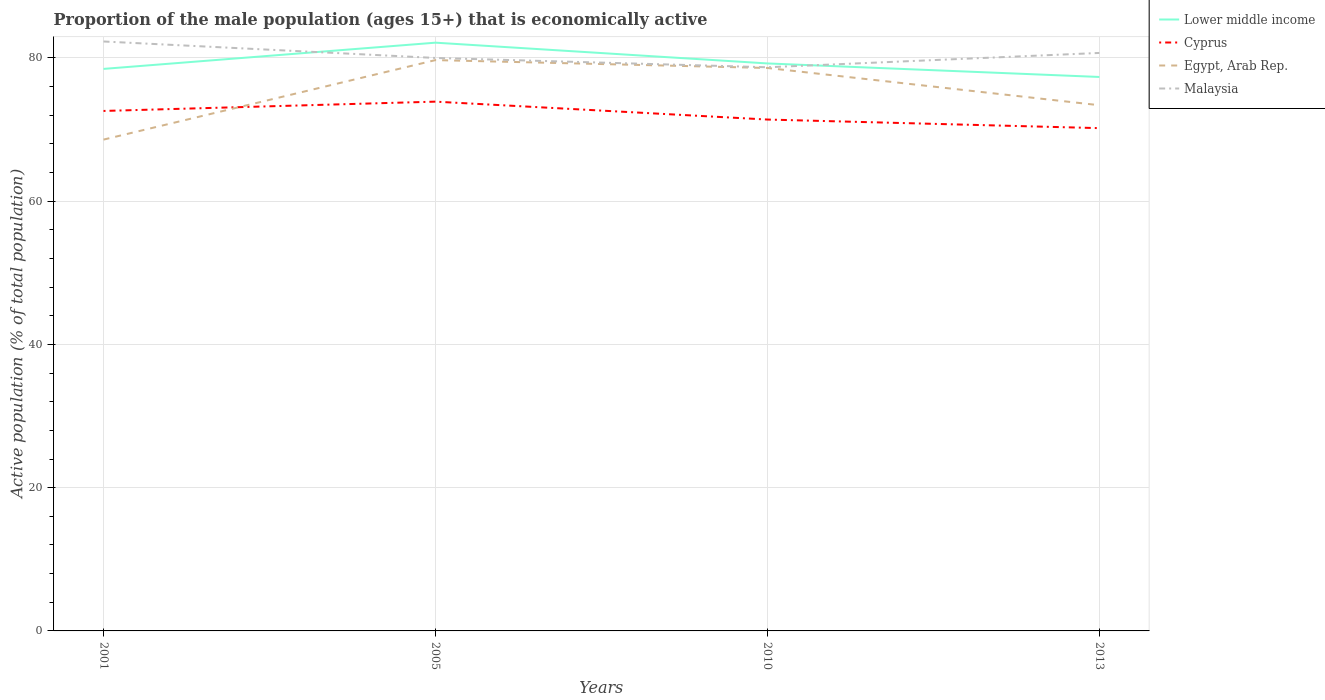How many different coloured lines are there?
Keep it short and to the point. 4. Is the number of lines equal to the number of legend labels?
Make the answer very short. Yes. Across all years, what is the maximum proportion of the male population that is economically active in Egypt, Arab Rep.?
Make the answer very short. 68.6. What is the total proportion of the male population that is economically active in Malaysia in the graph?
Keep it short and to the point. 3.6. What is the difference between the highest and the second highest proportion of the male population that is economically active in Lower middle income?
Your response must be concise. 4.79. What is the difference between the highest and the lowest proportion of the male population that is economically active in Malaysia?
Ensure brevity in your answer.  2. How many lines are there?
Keep it short and to the point. 4. How many years are there in the graph?
Give a very brief answer. 4. What is the difference between two consecutive major ticks on the Y-axis?
Provide a short and direct response. 20. Does the graph contain any zero values?
Your response must be concise. No. Does the graph contain grids?
Give a very brief answer. Yes. What is the title of the graph?
Give a very brief answer. Proportion of the male population (ages 15+) that is economically active. What is the label or title of the X-axis?
Ensure brevity in your answer.  Years. What is the label or title of the Y-axis?
Your answer should be very brief. Active population (% of total population). What is the Active population (% of total population) of Lower middle income in 2001?
Your answer should be very brief. 78.47. What is the Active population (% of total population) in Cyprus in 2001?
Give a very brief answer. 72.6. What is the Active population (% of total population) in Egypt, Arab Rep. in 2001?
Provide a short and direct response. 68.6. What is the Active population (% of total population) of Malaysia in 2001?
Your response must be concise. 82.3. What is the Active population (% of total population) in Lower middle income in 2005?
Offer a very short reply. 82.13. What is the Active population (% of total population) in Cyprus in 2005?
Offer a very short reply. 73.9. What is the Active population (% of total population) in Egypt, Arab Rep. in 2005?
Ensure brevity in your answer.  79.7. What is the Active population (% of total population) in Malaysia in 2005?
Your response must be concise. 80. What is the Active population (% of total population) in Lower middle income in 2010?
Your answer should be compact. 79.24. What is the Active population (% of total population) of Cyprus in 2010?
Your response must be concise. 71.4. What is the Active population (% of total population) of Egypt, Arab Rep. in 2010?
Provide a succinct answer. 78.6. What is the Active population (% of total population) of Malaysia in 2010?
Provide a succinct answer. 78.7. What is the Active population (% of total population) of Lower middle income in 2013?
Provide a short and direct response. 77.34. What is the Active population (% of total population) of Cyprus in 2013?
Make the answer very short. 70.2. What is the Active population (% of total population) of Egypt, Arab Rep. in 2013?
Your answer should be very brief. 73.4. What is the Active population (% of total population) of Malaysia in 2013?
Offer a very short reply. 80.7. Across all years, what is the maximum Active population (% of total population) of Lower middle income?
Your response must be concise. 82.13. Across all years, what is the maximum Active population (% of total population) of Cyprus?
Give a very brief answer. 73.9. Across all years, what is the maximum Active population (% of total population) in Egypt, Arab Rep.?
Ensure brevity in your answer.  79.7. Across all years, what is the maximum Active population (% of total population) in Malaysia?
Make the answer very short. 82.3. Across all years, what is the minimum Active population (% of total population) in Lower middle income?
Keep it short and to the point. 77.34. Across all years, what is the minimum Active population (% of total population) of Cyprus?
Ensure brevity in your answer.  70.2. Across all years, what is the minimum Active population (% of total population) of Egypt, Arab Rep.?
Your answer should be compact. 68.6. Across all years, what is the minimum Active population (% of total population) of Malaysia?
Offer a very short reply. 78.7. What is the total Active population (% of total population) of Lower middle income in the graph?
Keep it short and to the point. 317.19. What is the total Active population (% of total population) in Cyprus in the graph?
Your answer should be very brief. 288.1. What is the total Active population (% of total population) of Egypt, Arab Rep. in the graph?
Ensure brevity in your answer.  300.3. What is the total Active population (% of total population) in Malaysia in the graph?
Make the answer very short. 321.7. What is the difference between the Active population (% of total population) of Lower middle income in 2001 and that in 2005?
Your response must be concise. -3.66. What is the difference between the Active population (% of total population) of Cyprus in 2001 and that in 2005?
Offer a very short reply. -1.3. What is the difference between the Active population (% of total population) in Egypt, Arab Rep. in 2001 and that in 2005?
Make the answer very short. -11.1. What is the difference between the Active population (% of total population) in Lower middle income in 2001 and that in 2010?
Give a very brief answer. -0.76. What is the difference between the Active population (% of total population) of Egypt, Arab Rep. in 2001 and that in 2010?
Your answer should be compact. -10. What is the difference between the Active population (% of total population) in Malaysia in 2001 and that in 2010?
Offer a very short reply. 3.6. What is the difference between the Active population (% of total population) of Lower middle income in 2001 and that in 2013?
Offer a terse response. 1.13. What is the difference between the Active population (% of total population) of Egypt, Arab Rep. in 2001 and that in 2013?
Ensure brevity in your answer.  -4.8. What is the difference between the Active population (% of total population) of Lower middle income in 2005 and that in 2010?
Provide a short and direct response. 2.9. What is the difference between the Active population (% of total population) of Cyprus in 2005 and that in 2010?
Give a very brief answer. 2.5. What is the difference between the Active population (% of total population) in Malaysia in 2005 and that in 2010?
Offer a terse response. 1.3. What is the difference between the Active population (% of total population) in Lower middle income in 2005 and that in 2013?
Your response must be concise. 4.79. What is the difference between the Active population (% of total population) in Cyprus in 2005 and that in 2013?
Provide a succinct answer. 3.7. What is the difference between the Active population (% of total population) of Egypt, Arab Rep. in 2005 and that in 2013?
Make the answer very short. 6.3. What is the difference between the Active population (% of total population) in Malaysia in 2005 and that in 2013?
Provide a short and direct response. -0.7. What is the difference between the Active population (% of total population) in Lower middle income in 2010 and that in 2013?
Your response must be concise. 1.89. What is the difference between the Active population (% of total population) in Cyprus in 2010 and that in 2013?
Your answer should be compact. 1.2. What is the difference between the Active population (% of total population) in Lower middle income in 2001 and the Active population (% of total population) in Cyprus in 2005?
Your response must be concise. 4.57. What is the difference between the Active population (% of total population) in Lower middle income in 2001 and the Active population (% of total population) in Egypt, Arab Rep. in 2005?
Offer a very short reply. -1.23. What is the difference between the Active population (% of total population) in Lower middle income in 2001 and the Active population (% of total population) in Malaysia in 2005?
Provide a succinct answer. -1.53. What is the difference between the Active population (% of total population) in Cyprus in 2001 and the Active population (% of total population) in Egypt, Arab Rep. in 2005?
Ensure brevity in your answer.  -7.1. What is the difference between the Active population (% of total population) in Lower middle income in 2001 and the Active population (% of total population) in Cyprus in 2010?
Ensure brevity in your answer.  7.07. What is the difference between the Active population (% of total population) in Lower middle income in 2001 and the Active population (% of total population) in Egypt, Arab Rep. in 2010?
Your response must be concise. -0.13. What is the difference between the Active population (% of total population) in Lower middle income in 2001 and the Active population (% of total population) in Malaysia in 2010?
Give a very brief answer. -0.23. What is the difference between the Active population (% of total population) of Cyprus in 2001 and the Active population (% of total population) of Egypt, Arab Rep. in 2010?
Offer a very short reply. -6. What is the difference between the Active population (% of total population) of Lower middle income in 2001 and the Active population (% of total population) of Cyprus in 2013?
Give a very brief answer. 8.27. What is the difference between the Active population (% of total population) in Lower middle income in 2001 and the Active population (% of total population) in Egypt, Arab Rep. in 2013?
Offer a very short reply. 5.07. What is the difference between the Active population (% of total population) in Lower middle income in 2001 and the Active population (% of total population) in Malaysia in 2013?
Offer a terse response. -2.23. What is the difference between the Active population (% of total population) of Cyprus in 2001 and the Active population (% of total population) of Egypt, Arab Rep. in 2013?
Your response must be concise. -0.8. What is the difference between the Active population (% of total population) of Egypt, Arab Rep. in 2001 and the Active population (% of total population) of Malaysia in 2013?
Your answer should be compact. -12.1. What is the difference between the Active population (% of total population) in Lower middle income in 2005 and the Active population (% of total population) in Cyprus in 2010?
Your answer should be very brief. 10.73. What is the difference between the Active population (% of total population) of Lower middle income in 2005 and the Active population (% of total population) of Egypt, Arab Rep. in 2010?
Your answer should be compact. 3.53. What is the difference between the Active population (% of total population) in Lower middle income in 2005 and the Active population (% of total population) in Malaysia in 2010?
Make the answer very short. 3.43. What is the difference between the Active population (% of total population) of Cyprus in 2005 and the Active population (% of total population) of Egypt, Arab Rep. in 2010?
Provide a succinct answer. -4.7. What is the difference between the Active population (% of total population) of Egypt, Arab Rep. in 2005 and the Active population (% of total population) of Malaysia in 2010?
Keep it short and to the point. 1. What is the difference between the Active population (% of total population) in Lower middle income in 2005 and the Active population (% of total population) in Cyprus in 2013?
Ensure brevity in your answer.  11.93. What is the difference between the Active population (% of total population) of Lower middle income in 2005 and the Active population (% of total population) of Egypt, Arab Rep. in 2013?
Your answer should be very brief. 8.73. What is the difference between the Active population (% of total population) of Lower middle income in 2005 and the Active population (% of total population) of Malaysia in 2013?
Offer a terse response. 1.43. What is the difference between the Active population (% of total population) in Cyprus in 2005 and the Active population (% of total population) in Egypt, Arab Rep. in 2013?
Your answer should be very brief. 0.5. What is the difference between the Active population (% of total population) of Cyprus in 2005 and the Active population (% of total population) of Malaysia in 2013?
Your response must be concise. -6.8. What is the difference between the Active population (% of total population) in Egypt, Arab Rep. in 2005 and the Active population (% of total population) in Malaysia in 2013?
Offer a terse response. -1. What is the difference between the Active population (% of total population) in Lower middle income in 2010 and the Active population (% of total population) in Cyprus in 2013?
Provide a succinct answer. 9.04. What is the difference between the Active population (% of total population) in Lower middle income in 2010 and the Active population (% of total population) in Egypt, Arab Rep. in 2013?
Ensure brevity in your answer.  5.83. What is the difference between the Active population (% of total population) in Lower middle income in 2010 and the Active population (% of total population) in Malaysia in 2013?
Offer a very short reply. -1.47. What is the difference between the Active population (% of total population) of Cyprus in 2010 and the Active population (% of total population) of Malaysia in 2013?
Give a very brief answer. -9.3. What is the average Active population (% of total population) in Lower middle income per year?
Your response must be concise. 79.3. What is the average Active population (% of total population) of Cyprus per year?
Your answer should be compact. 72.03. What is the average Active population (% of total population) in Egypt, Arab Rep. per year?
Provide a short and direct response. 75.08. What is the average Active population (% of total population) in Malaysia per year?
Keep it short and to the point. 80.42. In the year 2001, what is the difference between the Active population (% of total population) in Lower middle income and Active population (% of total population) in Cyprus?
Ensure brevity in your answer.  5.87. In the year 2001, what is the difference between the Active population (% of total population) of Lower middle income and Active population (% of total population) of Egypt, Arab Rep.?
Provide a succinct answer. 9.87. In the year 2001, what is the difference between the Active population (% of total population) of Lower middle income and Active population (% of total population) of Malaysia?
Make the answer very short. -3.83. In the year 2001, what is the difference between the Active population (% of total population) of Egypt, Arab Rep. and Active population (% of total population) of Malaysia?
Provide a short and direct response. -13.7. In the year 2005, what is the difference between the Active population (% of total population) in Lower middle income and Active population (% of total population) in Cyprus?
Your answer should be compact. 8.23. In the year 2005, what is the difference between the Active population (% of total population) in Lower middle income and Active population (% of total population) in Egypt, Arab Rep.?
Your answer should be very brief. 2.43. In the year 2005, what is the difference between the Active population (% of total population) of Lower middle income and Active population (% of total population) of Malaysia?
Provide a succinct answer. 2.13. In the year 2010, what is the difference between the Active population (% of total population) in Lower middle income and Active population (% of total population) in Cyprus?
Make the answer very short. 7.83. In the year 2010, what is the difference between the Active population (% of total population) of Lower middle income and Active population (% of total population) of Egypt, Arab Rep.?
Offer a very short reply. 0.64. In the year 2010, what is the difference between the Active population (% of total population) of Lower middle income and Active population (% of total population) of Malaysia?
Keep it short and to the point. 0.54. In the year 2010, what is the difference between the Active population (% of total population) of Cyprus and Active population (% of total population) of Egypt, Arab Rep.?
Offer a terse response. -7.2. In the year 2010, what is the difference between the Active population (% of total population) of Cyprus and Active population (% of total population) of Malaysia?
Make the answer very short. -7.3. In the year 2013, what is the difference between the Active population (% of total population) in Lower middle income and Active population (% of total population) in Cyprus?
Your answer should be compact. 7.14. In the year 2013, what is the difference between the Active population (% of total population) of Lower middle income and Active population (% of total population) of Egypt, Arab Rep.?
Provide a succinct answer. 3.94. In the year 2013, what is the difference between the Active population (% of total population) in Lower middle income and Active population (% of total population) in Malaysia?
Your response must be concise. -3.36. In the year 2013, what is the difference between the Active population (% of total population) in Cyprus and Active population (% of total population) in Egypt, Arab Rep.?
Give a very brief answer. -3.2. In the year 2013, what is the difference between the Active population (% of total population) in Cyprus and Active population (% of total population) in Malaysia?
Offer a terse response. -10.5. What is the ratio of the Active population (% of total population) in Lower middle income in 2001 to that in 2005?
Offer a terse response. 0.96. What is the ratio of the Active population (% of total population) in Cyprus in 2001 to that in 2005?
Offer a very short reply. 0.98. What is the ratio of the Active population (% of total population) in Egypt, Arab Rep. in 2001 to that in 2005?
Ensure brevity in your answer.  0.86. What is the ratio of the Active population (% of total population) of Malaysia in 2001 to that in 2005?
Keep it short and to the point. 1.03. What is the ratio of the Active population (% of total population) of Lower middle income in 2001 to that in 2010?
Your answer should be compact. 0.99. What is the ratio of the Active population (% of total population) of Cyprus in 2001 to that in 2010?
Provide a succinct answer. 1.02. What is the ratio of the Active population (% of total population) in Egypt, Arab Rep. in 2001 to that in 2010?
Keep it short and to the point. 0.87. What is the ratio of the Active population (% of total population) of Malaysia in 2001 to that in 2010?
Provide a short and direct response. 1.05. What is the ratio of the Active population (% of total population) in Lower middle income in 2001 to that in 2013?
Offer a terse response. 1.01. What is the ratio of the Active population (% of total population) of Cyprus in 2001 to that in 2013?
Your response must be concise. 1.03. What is the ratio of the Active population (% of total population) of Egypt, Arab Rep. in 2001 to that in 2013?
Provide a short and direct response. 0.93. What is the ratio of the Active population (% of total population) in Malaysia in 2001 to that in 2013?
Offer a terse response. 1.02. What is the ratio of the Active population (% of total population) in Lower middle income in 2005 to that in 2010?
Offer a terse response. 1.04. What is the ratio of the Active population (% of total population) of Cyprus in 2005 to that in 2010?
Offer a terse response. 1.03. What is the ratio of the Active population (% of total population) of Malaysia in 2005 to that in 2010?
Offer a very short reply. 1.02. What is the ratio of the Active population (% of total population) of Lower middle income in 2005 to that in 2013?
Give a very brief answer. 1.06. What is the ratio of the Active population (% of total population) in Cyprus in 2005 to that in 2013?
Offer a terse response. 1.05. What is the ratio of the Active population (% of total population) in Egypt, Arab Rep. in 2005 to that in 2013?
Offer a terse response. 1.09. What is the ratio of the Active population (% of total population) of Lower middle income in 2010 to that in 2013?
Your response must be concise. 1.02. What is the ratio of the Active population (% of total population) of Cyprus in 2010 to that in 2013?
Make the answer very short. 1.02. What is the ratio of the Active population (% of total population) of Egypt, Arab Rep. in 2010 to that in 2013?
Your answer should be compact. 1.07. What is the ratio of the Active population (% of total population) of Malaysia in 2010 to that in 2013?
Offer a very short reply. 0.98. What is the difference between the highest and the second highest Active population (% of total population) in Lower middle income?
Provide a short and direct response. 2.9. What is the difference between the highest and the second highest Active population (% of total population) in Cyprus?
Provide a short and direct response. 1.3. What is the difference between the highest and the second highest Active population (% of total population) of Egypt, Arab Rep.?
Your response must be concise. 1.1. What is the difference between the highest and the second highest Active population (% of total population) of Malaysia?
Offer a very short reply. 1.6. What is the difference between the highest and the lowest Active population (% of total population) in Lower middle income?
Your answer should be compact. 4.79. What is the difference between the highest and the lowest Active population (% of total population) of Cyprus?
Your answer should be compact. 3.7. What is the difference between the highest and the lowest Active population (% of total population) in Egypt, Arab Rep.?
Provide a succinct answer. 11.1. 